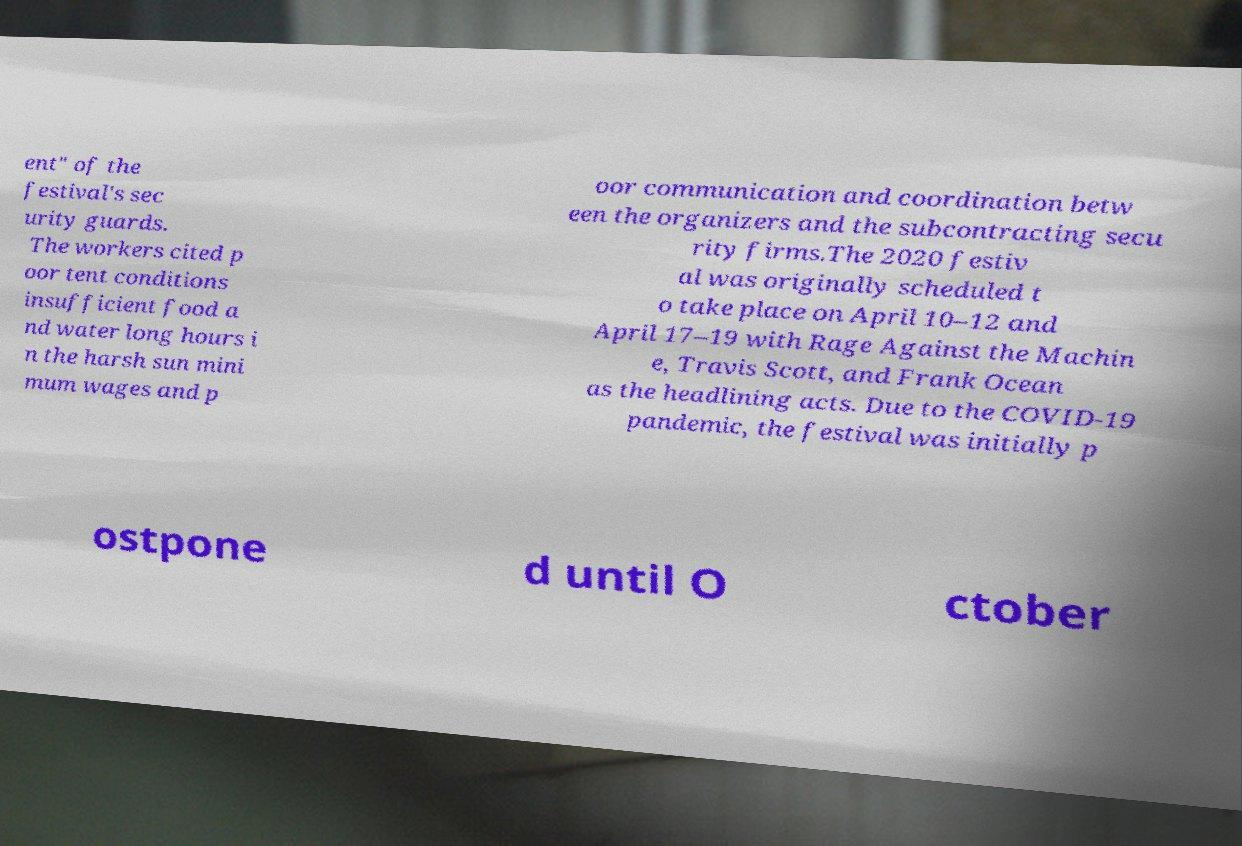Please identify and transcribe the text found in this image. ent" of the festival's sec urity guards. The workers cited p oor tent conditions insufficient food a nd water long hours i n the harsh sun mini mum wages and p oor communication and coordination betw een the organizers and the subcontracting secu rity firms.The 2020 festiv al was originally scheduled t o take place on April 10–12 and April 17–19 with Rage Against the Machin e, Travis Scott, and Frank Ocean as the headlining acts. Due to the COVID-19 pandemic, the festival was initially p ostpone d until O ctober 